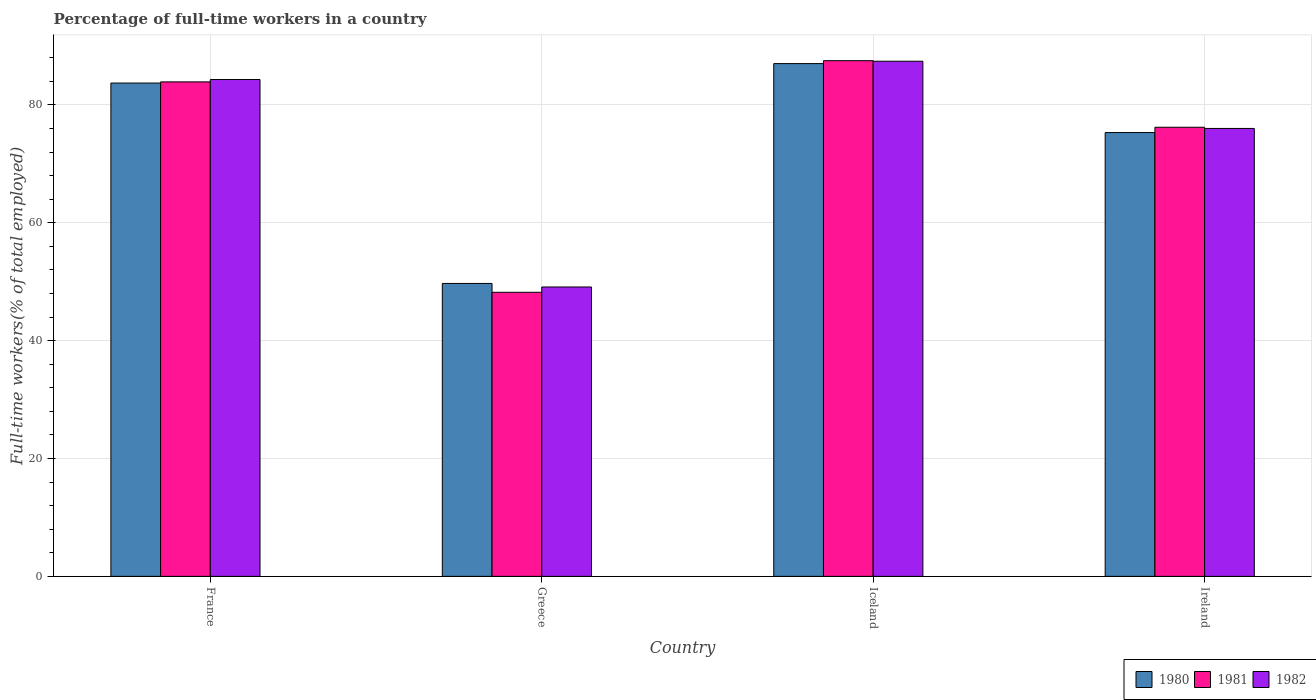How many different coloured bars are there?
Provide a succinct answer. 3. What is the percentage of full-time workers in 1982 in France?
Provide a short and direct response. 84.3. Across all countries, what is the minimum percentage of full-time workers in 1980?
Provide a succinct answer. 49.7. In which country was the percentage of full-time workers in 1981 maximum?
Your response must be concise. Iceland. In which country was the percentage of full-time workers in 1982 minimum?
Offer a very short reply. Greece. What is the total percentage of full-time workers in 1982 in the graph?
Offer a very short reply. 296.8. What is the difference between the percentage of full-time workers in 1982 in France and that in Iceland?
Offer a very short reply. -3.1. What is the difference between the percentage of full-time workers in 1980 in France and the percentage of full-time workers in 1981 in Iceland?
Give a very brief answer. -3.8. What is the average percentage of full-time workers in 1980 per country?
Give a very brief answer. 73.93. What is the difference between the percentage of full-time workers of/in 1980 and percentage of full-time workers of/in 1981 in Ireland?
Make the answer very short. -0.9. What is the ratio of the percentage of full-time workers in 1982 in France to that in Ireland?
Offer a terse response. 1.11. Is the difference between the percentage of full-time workers in 1980 in France and Greece greater than the difference between the percentage of full-time workers in 1981 in France and Greece?
Provide a succinct answer. No. What is the difference between the highest and the second highest percentage of full-time workers in 1982?
Keep it short and to the point. 8.3. What is the difference between the highest and the lowest percentage of full-time workers in 1980?
Your answer should be very brief. 37.3. In how many countries, is the percentage of full-time workers in 1982 greater than the average percentage of full-time workers in 1982 taken over all countries?
Offer a very short reply. 3. Is the sum of the percentage of full-time workers in 1981 in France and Iceland greater than the maximum percentage of full-time workers in 1982 across all countries?
Your answer should be very brief. Yes. What does the 1st bar from the left in Greece represents?
Keep it short and to the point. 1980. Is it the case that in every country, the sum of the percentage of full-time workers in 1980 and percentage of full-time workers in 1982 is greater than the percentage of full-time workers in 1981?
Give a very brief answer. Yes. Are all the bars in the graph horizontal?
Provide a succinct answer. No. What is the difference between two consecutive major ticks on the Y-axis?
Offer a very short reply. 20. How many legend labels are there?
Ensure brevity in your answer.  3. How are the legend labels stacked?
Provide a short and direct response. Horizontal. What is the title of the graph?
Your response must be concise. Percentage of full-time workers in a country. What is the label or title of the X-axis?
Your answer should be compact. Country. What is the label or title of the Y-axis?
Keep it short and to the point. Full-time workers(% of total employed). What is the Full-time workers(% of total employed) in 1980 in France?
Give a very brief answer. 83.7. What is the Full-time workers(% of total employed) in 1981 in France?
Keep it short and to the point. 83.9. What is the Full-time workers(% of total employed) in 1982 in France?
Your answer should be compact. 84.3. What is the Full-time workers(% of total employed) of 1980 in Greece?
Your answer should be compact. 49.7. What is the Full-time workers(% of total employed) of 1981 in Greece?
Provide a succinct answer. 48.2. What is the Full-time workers(% of total employed) in 1982 in Greece?
Your answer should be compact. 49.1. What is the Full-time workers(% of total employed) of 1981 in Iceland?
Provide a succinct answer. 87.5. What is the Full-time workers(% of total employed) of 1982 in Iceland?
Ensure brevity in your answer.  87.4. What is the Full-time workers(% of total employed) in 1980 in Ireland?
Provide a short and direct response. 75.3. What is the Full-time workers(% of total employed) in 1981 in Ireland?
Provide a succinct answer. 76.2. Across all countries, what is the maximum Full-time workers(% of total employed) of 1981?
Your answer should be compact. 87.5. Across all countries, what is the maximum Full-time workers(% of total employed) of 1982?
Your answer should be very brief. 87.4. Across all countries, what is the minimum Full-time workers(% of total employed) of 1980?
Your answer should be compact. 49.7. Across all countries, what is the minimum Full-time workers(% of total employed) of 1981?
Make the answer very short. 48.2. Across all countries, what is the minimum Full-time workers(% of total employed) in 1982?
Give a very brief answer. 49.1. What is the total Full-time workers(% of total employed) in 1980 in the graph?
Provide a succinct answer. 295.7. What is the total Full-time workers(% of total employed) in 1981 in the graph?
Your answer should be very brief. 295.8. What is the total Full-time workers(% of total employed) in 1982 in the graph?
Give a very brief answer. 296.8. What is the difference between the Full-time workers(% of total employed) of 1980 in France and that in Greece?
Your answer should be compact. 34. What is the difference between the Full-time workers(% of total employed) in 1981 in France and that in Greece?
Make the answer very short. 35.7. What is the difference between the Full-time workers(% of total employed) in 1982 in France and that in Greece?
Provide a short and direct response. 35.2. What is the difference between the Full-time workers(% of total employed) in 1982 in France and that in Iceland?
Provide a short and direct response. -3.1. What is the difference between the Full-time workers(% of total employed) of 1980 in France and that in Ireland?
Your answer should be very brief. 8.4. What is the difference between the Full-time workers(% of total employed) in 1980 in Greece and that in Iceland?
Give a very brief answer. -37.3. What is the difference between the Full-time workers(% of total employed) in 1981 in Greece and that in Iceland?
Make the answer very short. -39.3. What is the difference between the Full-time workers(% of total employed) in 1982 in Greece and that in Iceland?
Your response must be concise. -38.3. What is the difference between the Full-time workers(% of total employed) in 1980 in Greece and that in Ireland?
Provide a short and direct response. -25.6. What is the difference between the Full-time workers(% of total employed) in 1982 in Greece and that in Ireland?
Provide a short and direct response. -26.9. What is the difference between the Full-time workers(% of total employed) of 1980 in Iceland and that in Ireland?
Your response must be concise. 11.7. What is the difference between the Full-time workers(% of total employed) in 1981 in Iceland and that in Ireland?
Provide a succinct answer. 11.3. What is the difference between the Full-time workers(% of total employed) of 1982 in Iceland and that in Ireland?
Offer a terse response. 11.4. What is the difference between the Full-time workers(% of total employed) of 1980 in France and the Full-time workers(% of total employed) of 1981 in Greece?
Your answer should be very brief. 35.5. What is the difference between the Full-time workers(% of total employed) of 1980 in France and the Full-time workers(% of total employed) of 1982 in Greece?
Make the answer very short. 34.6. What is the difference between the Full-time workers(% of total employed) of 1981 in France and the Full-time workers(% of total employed) of 1982 in Greece?
Keep it short and to the point. 34.8. What is the difference between the Full-time workers(% of total employed) of 1980 in France and the Full-time workers(% of total employed) of 1982 in Iceland?
Your response must be concise. -3.7. What is the difference between the Full-time workers(% of total employed) in 1980 in France and the Full-time workers(% of total employed) in 1982 in Ireland?
Your response must be concise. 7.7. What is the difference between the Full-time workers(% of total employed) of 1980 in Greece and the Full-time workers(% of total employed) of 1981 in Iceland?
Offer a terse response. -37.8. What is the difference between the Full-time workers(% of total employed) in 1980 in Greece and the Full-time workers(% of total employed) in 1982 in Iceland?
Offer a very short reply. -37.7. What is the difference between the Full-time workers(% of total employed) of 1981 in Greece and the Full-time workers(% of total employed) of 1982 in Iceland?
Provide a short and direct response. -39.2. What is the difference between the Full-time workers(% of total employed) in 1980 in Greece and the Full-time workers(% of total employed) in 1981 in Ireland?
Ensure brevity in your answer.  -26.5. What is the difference between the Full-time workers(% of total employed) of 1980 in Greece and the Full-time workers(% of total employed) of 1982 in Ireland?
Give a very brief answer. -26.3. What is the difference between the Full-time workers(% of total employed) of 1981 in Greece and the Full-time workers(% of total employed) of 1982 in Ireland?
Your answer should be compact. -27.8. What is the difference between the Full-time workers(% of total employed) in 1980 in Iceland and the Full-time workers(% of total employed) in 1981 in Ireland?
Make the answer very short. 10.8. What is the difference between the Full-time workers(% of total employed) in 1981 in Iceland and the Full-time workers(% of total employed) in 1982 in Ireland?
Your answer should be compact. 11.5. What is the average Full-time workers(% of total employed) in 1980 per country?
Your answer should be compact. 73.92. What is the average Full-time workers(% of total employed) in 1981 per country?
Ensure brevity in your answer.  73.95. What is the average Full-time workers(% of total employed) in 1982 per country?
Provide a succinct answer. 74.2. What is the difference between the Full-time workers(% of total employed) of 1981 and Full-time workers(% of total employed) of 1982 in France?
Your response must be concise. -0.4. What is the difference between the Full-time workers(% of total employed) in 1980 and Full-time workers(% of total employed) in 1981 in Greece?
Offer a very short reply. 1.5. What is the difference between the Full-time workers(% of total employed) of 1981 and Full-time workers(% of total employed) of 1982 in Greece?
Offer a very short reply. -0.9. What is the difference between the Full-time workers(% of total employed) in 1980 and Full-time workers(% of total employed) in 1982 in Iceland?
Your answer should be compact. -0.4. What is the difference between the Full-time workers(% of total employed) in 1981 and Full-time workers(% of total employed) in 1982 in Iceland?
Your answer should be very brief. 0.1. What is the difference between the Full-time workers(% of total employed) in 1980 and Full-time workers(% of total employed) in 1982 in Ireland?
Make the answer very short. -0.7. What is the difference between the Full-time workers(% of total employed) of 1981 and Full-time workers(% of total employed) of 1982 in Ireland?
Make the answer very short. 0.2. What is the ratio of the Full-time workers(% of total employed) in 1980 in France to that in Greece?
Give a very brief answer. 1.68. What is the ratio of the Full-time workers(% of total employed) of 1981 in France to that in Greece?
Offer a very short reply. 1.74. What is the ratio of the Full-time workers(% of total employed) of 1982 in France to that in Greece?
Provide a short and direct response. 1.72. What is the ratio of the Full-time workers(% of total employed) of 1980 in France to that in Iceland?
Offer a very short reply. 0.96. What is the ratio of the Full-time workers(% of total employed) in 1981 in France to that in Iceland?
Give a very brief answer. 0.96. What is the ratio of the Full-time workers(% of total employed) in 1982 in France to that in Iceland?
Your answer should be compact. 0.96. What is the ratio of the Full-time workers(% of total employed) in 1980 in France to that in Ireland?
Give a very brief answer. 1.11. What is the ratio of the Full-time workers(% of total employed) of 1981 in France to that in Ireland?
Offer a terse response. 1.1. What is the ratio of the Full-time workers(% of total employed) of 1982 in France to that in Ireland?
Your response must be concise. 1.11. What is the ratio of the Full-time workers(% of total employed) of 1980 in Greece to that in Iceland?
Ensure brevity in your answer.  0.57. What is the ratio of the Full-time workers(% of total employed) of 1981 in Greece to that in Iceland?
Give a very brief answer. 0.55. What is the ratio of the Full-time workers(% of total employed) in 1982 in Greece to that in Iceland?
Provide a short and direct response. 0.56. What is the ratio of the Full-time workers(% of total employed) in 1980 in Greece to that in Ireland?
Ensure brevity in your answer.  0.66. What is the ratio of the Full-time workers(% of total employed) of 1981 in Greece to that in Ireland?
Keep it short and to the point. 0.63. What is the ratio of the Full-time workers(% of total employed) of 1982 in Greece to that in Ireland?
Your answer should be very brief. 0.65. What is the ratio of the Full-time workers(% of total employed) in 1980 in Iceland to that in Ireland?
Provide a short and direct response. 1.16. What is the ratio of the Full-time workers(% of total employed) in 1981 in Iceland to that in Ireland?
Give a very brief answer. 1.15. What is the ratio of the Full-time workers(% of total employed) of 1982 in Iceland to that in Ireland?
Provide a short and direct response. 1.15. What is the difference between the highest and the second highest Full-time workers(% of total employed) in 1981?
Ensure brevity in your answer.  3.6. What is the difference between the highest and the second highest Full-time workers(% of total employed) of 1982?
Provide a succinct answer. 3.1. What is the difference between the highest and the lowest Full-time workers(% of total employed) of 1980?
Give a very brief answer. 37.3. What is the difference between the highest and the lowest Full-time workers(% of total employed) of 1981?
Ensure brevity in your answer.  39.3. What is the difference between the highest and the lowest Full-time workers(% of total employed) of 1982?
Your response must be concise. 38.3. 